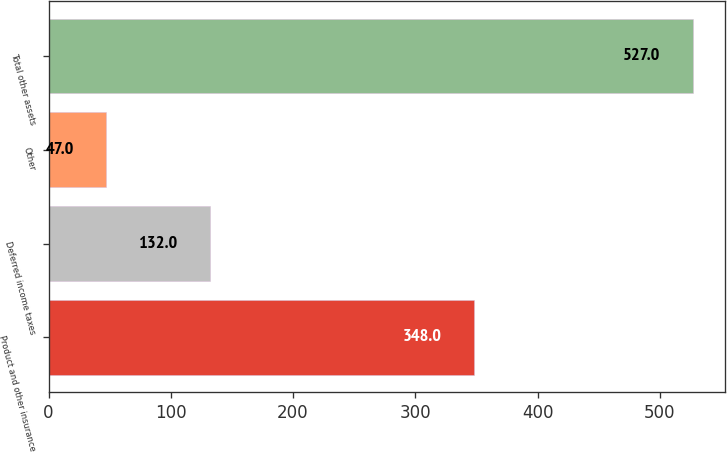Convert chart to OTSL. <chart><loc_0><loc_0><loc_500><loc_500><bar_chart><fcel>Product and other insurance<fcel>Deferred income taxes<fcel>Other<fcel>Total other assets<nl><fcel>348<fcel>132<fcel>47<fcel>527<nl></chart> 